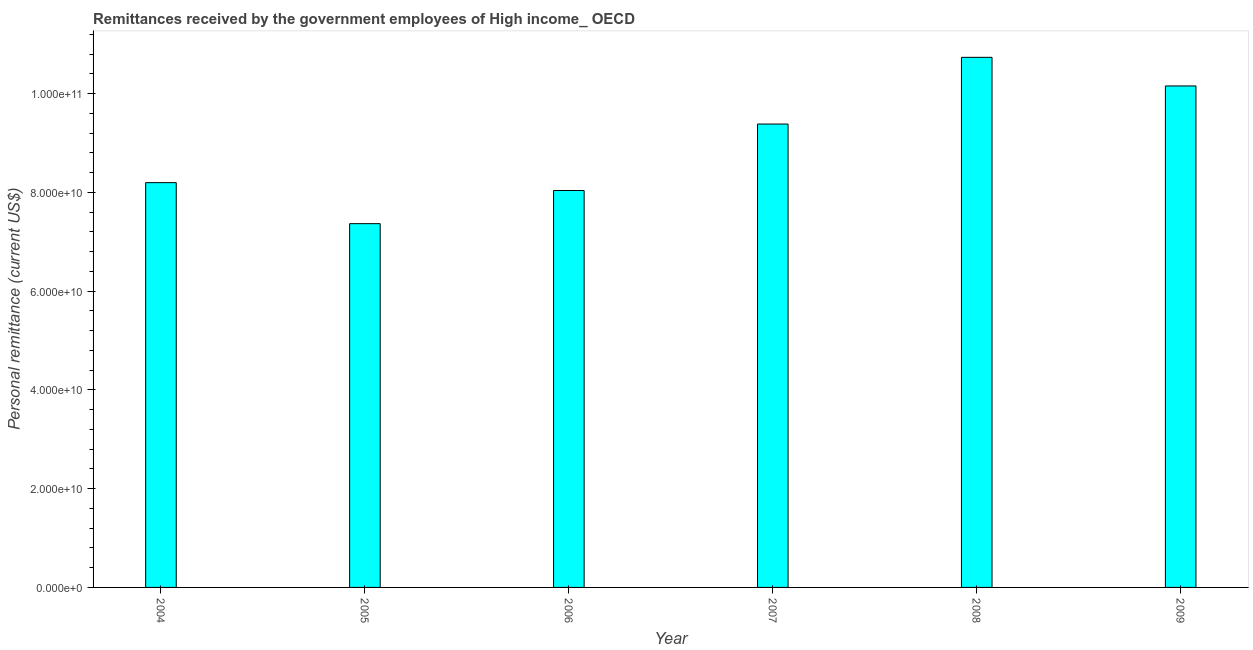What is the title of the graph?
Offer a very short reply. Remittances received by the government employees of High income_ OECD. What is the label or title of the X-axis?
Give a very brief answer. Year. What is the label or title of the Y-axis?
Your response must be concise. Personal remittance (current US$). What is the personal remittances in 2008?
Offer a terse response. 1.07e+11. Across all years, what is the maximum personal remittances?
Your answer should be compact. 1.07e+11. Across all years, what is the minimum personal remittances?
Offer a terse response. 7.37e+1. In which year was the personal remittances maximum?
Ensure brevity in your answer.  2008. In which year was the personal remittances minimum?
Offer a very short reply. 2005. What is the sum of the personal remittances?
Offer a very short reply. 5.39e+11. What is the difference between the personal remittances in 2008 and 2009?
Provide a short and direct response. 5.80e+09. What is the average personal remittances per year?
Keep it short and to the point. 8.98e+1. What is the median personal remittances?
Ensure brevity in your answer.  8.79e+1. In how many years, is the personal remittances greater than 16000000000 US$?
Give a very brief answer. 6. Do a majority of the years between 2008 and 2009 (inclusive) have personal remittances greater than 68000000000 US$?
Make the answer very short. Yes. What is the ratio of the personal remittances in 2004 to that in 2009?
Give a very brief answer. 0.81. Is the personal remittances in 2004 less than that in 2007?
Offer a very short reply. Yes. Is the difference between the personal remittances in 2004 and 2008 greater than the difference between any two years?
Your response must be concise. No. What is the difference between the highest and the second highest personal remittances?
Ensure brevity in your answer.  5.80e+09. What is the difference between the highest and the lowest personal remittances?
Your answer should be compact. 3.37e+1. Are all the bars in the graph horizontal?
Give a very brief answer. No. How many years are there in the graph?
Give a very brief answer. 6. What is the difference between two consecutive major ticks on the Y-axis?
Your response must be concise. 2.00e+1. What is the Personal remittance (current US$) of 2004?
Offer a very short reply. 8.20e+1. What is the Personal remittance (current US$) in 2005?
Keep it short and to the point. 7.37e+1. What is the Personal remittance (current US$) in 2006?
Keep it short and to the point. 8.04e+1. What is the Personal remittance (current US$) in 2007?
Give a very brief answer. 9.38e+1. What is the Personal remittance (current US$) in 2008?
Your response must be concise. 1.07e+11. What is the Personal remittance (current US$) in 2009?
Your answer should be compact. 1.02e+11. What is the difference between the Personal remittance (current US$) in 2004 and 2005?
Provide a succinct answer. 8.31e+09. What is the difference between the Personal remittance (current US$) in 2004 and 2006?
Make the answer very short. 1.59e+09. What is the difference between the Personal remittance (current US$) in 2004 and 2007?
Your response must be concise. -1.19e+1. What is the difference between the Personal remittance (current US$) in 2004 and 2008?
Give a very brief answer. -2.54e+1. What is the difference between the Personal remittance (current US$) in 2004 and 2009?
Provide a short and direct response. -1.96e+1. What is the difference between the Personal remittance (current US$) in 2005 and 2006?
Offer a very short reply. -6.72e+09. What is the difference between the Personal remittance (current US$) in 2005 and 2007?
Offer a terse response. -2.02e+1. What is the difference between the Personal remittance (current US$) in 2005 and 2008?
Make the answer very short. -3.37e+1. What is the difference between the Personal remittance (current US$) in 2005 and 2009?
Your answer should be compact. -2.79e+1. What is the difference between the Personal remittance (current US$) in 2006 and 2007?
Ensure brevity in your answer.  -1.35e+1. What is the difference between the Personal remittance (current US$) in 2006 and 2008?
Your response must be concise. -2.70e+1. What is the difference between the Personal remittance (current US$) in 2006 and 2009?
Your answer should be compact. -2.12e+1. What is the difference between the Personal remittance (current US$) in 2007 and 2008?
Provide a succinct answer. -1.35e+1. What is the difference between the Personal remittance (current US$) in 2007 and 2009?
Offer a terse response. -7.71e+09. What is the difference between the Personal remittance (current US$) in 2008 and 2009?
Keep it short and to the point. 5.80e+09. What is the ratio of the Personal remittance (current US$) in 2004 to that in 2005?
Offer a very short reply. 1.11. What is the ratio of the Personal remittance (current US$) in 2004 to that in 2007?
Offer a terse response. 0.87. What is the ratio of the Personal remittance (current US$) in 2004 to that in 2008?
Ensure brevity in your answer.  0.76. What is the ratio of the Personal remittance (current US$) in 2004 to that in 2009?
Provide a short and direct response. 0.81. What is the ratio of the Personal remittance (current US$) in 2005 to that in 2006?
Your answer should be compact. 0.92. What is the ratio of the Personal remittance (current US$) in 2005 to that in 2007?
Your answer should be very brief. 0.79. What is the ratio of the Personal remittance (current US$) in 2005 to that in 2008?
Your answer should be compact. 0.69. What is the ratio of the Personal remittance (current US$) in 2005 to that in 2009?
Your response must be concise. 0.72. What is the ratio of the Personal remittance (current US$) in 2006 to that in 2007?
Provide a succinct answer. 0.86. What is the ratio of the Personal remittance (current US$) in 2006 to that in 2008?
Give a very brief answer. 0.75. What is the ratio of the Personal remittance (current US$) in 2006 to that in 2009?
Keep it short and to the point. 0.79. What is the ratio of the Personal remittance (current US$) in 2007 to that in 2008?
Your answer should be very brief. 0.87. What is the ratio of the Personal remittance (current US$) in 2007 to that in 2009?
Your answer should be very brief. 0.92. What is the ratio of the Personal remittance (current US$) in 2008 to that in 2009?
Provide a short and direct response. 1.06. 